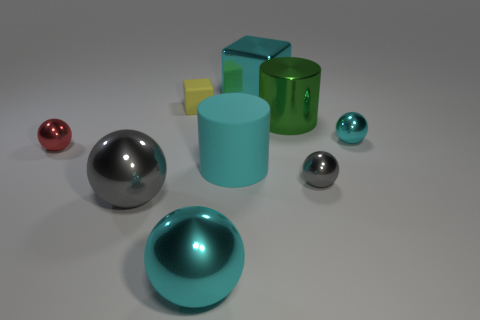Subtract all yellow balls. Subtract all purple cylinders. How many balls are left? 5 Add 1 small gray balls. How many objects exist? 10 Subtract all cubes. How many objects are left? 7 Subtract 1 cyan cylinders. How many objects are left? 8 Subtract all large spheres. Subtract all big green metallic objects. How many objects are left? 6 Add 4 cyan blocks. How many cyan blocks are left? 5 Add 4 large brown metallic cubes. How many large brown metallic cubes exist? 4 